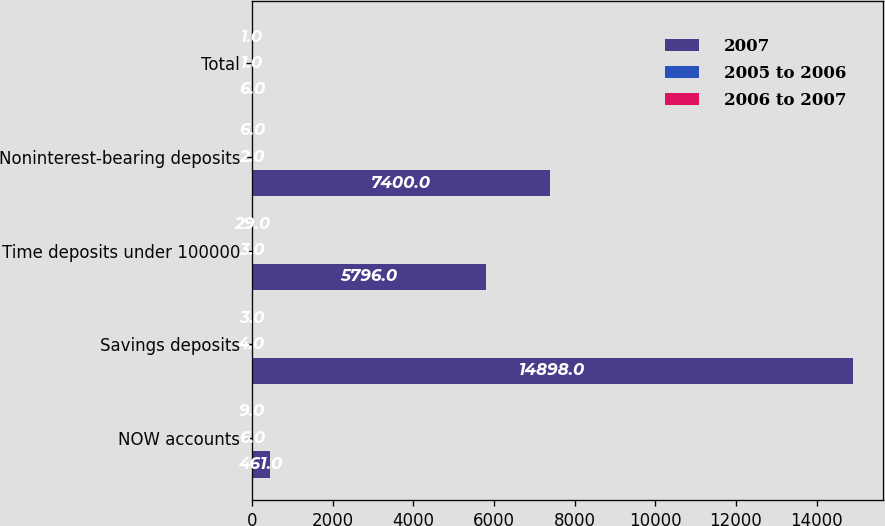Convert chart to OTSL. <chart><loc_0><loc_0><loc_500><loc_500><stacked_bar_chart><ecel><fcel>NOW accounts<fcel>Savings deposits<fcel>Time deposits under 100000<fcel>Noninterest-bearing deposits<fcel>Total<nl><fcel>2007<fcel>461<fcel>14898<fcel>5796<fcel>7400<fcel>6<nl><fcel>2005 to 2006<fcel>6<fcel>4<fcel>3<fcel>2<fcel>1<nl><fcel>2006 to 2007<fcel>9<fcel>3<fcel>29<fcel>6<fcel>1<nl></chart> 